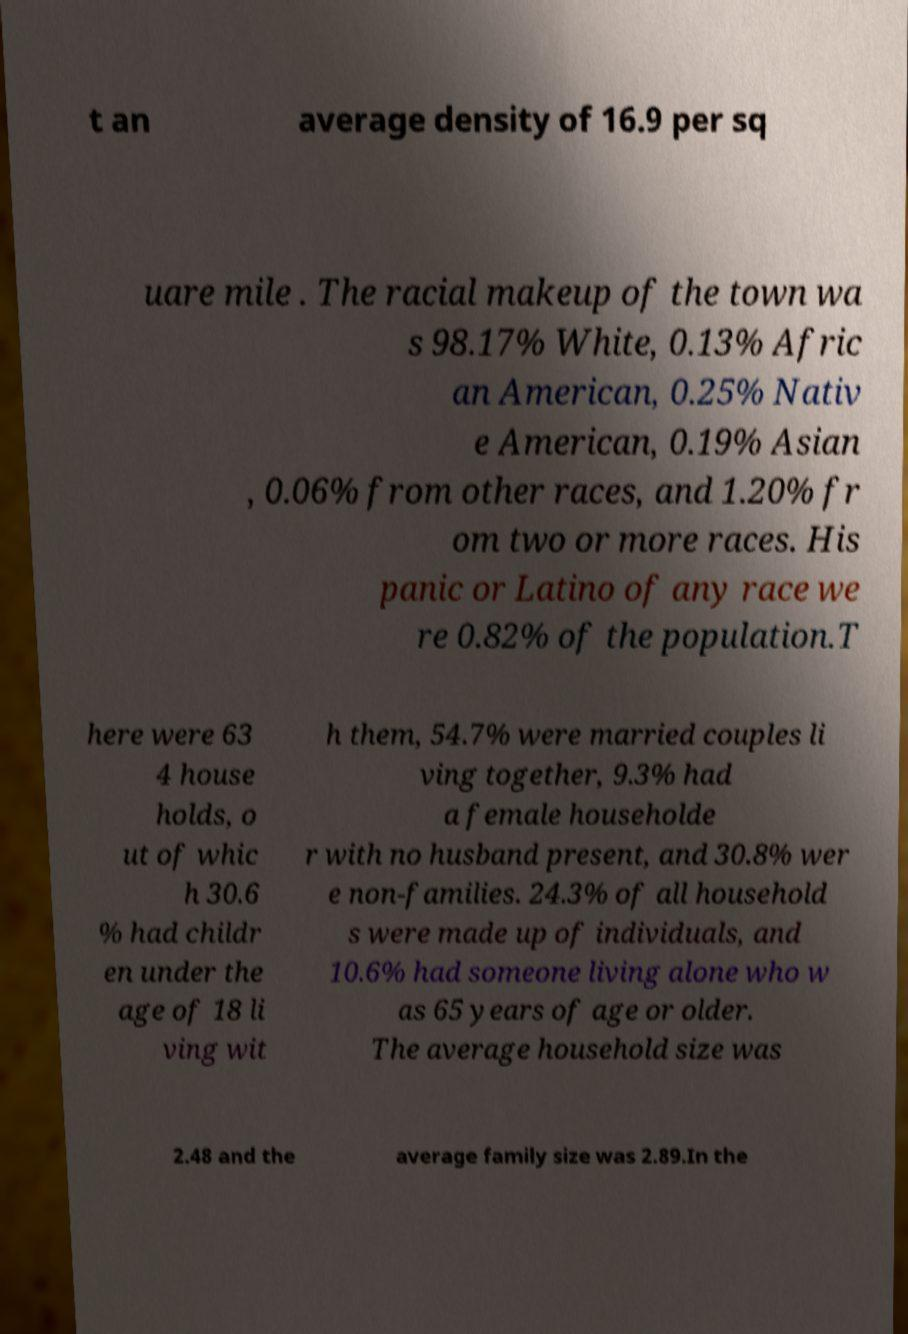Could you extract and type out the text from this image? t an average density of 16.9 per sq uare mile . The racial makeup of the town wa s 98.17% White, 0.13% Afric an American, 0.25% Nativ e American, 0.19% Asian , 0.06% from other races, and 1.20% fr om two or more races. His panic or Latino of any race we re 0.82% of the population.T here were 63 4 house holds, o ut of whic h 30.6 % had childr en under the age of 18 li ving wit h them, 54.7% were married couples li ving together, 9.3% had a female householde r with no husband present, and 30.8% wer e non-families. 24.3% of all household s were made up of individuals, and 10.6% had someone living alone who w as 65 years of age or older. The average household size was 2.48 and the average family size was 2.89.In the 